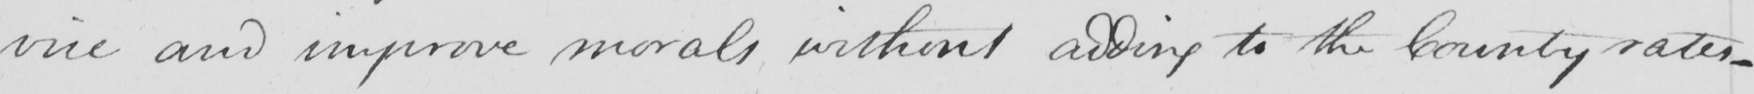Transcribe the text shown in this historical manuscript line. vice and improve morals without adding to the County rates  _ 